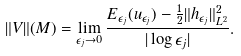Convert formula to latex. <formula><loc_0><loc_0><loc_500><loc_500>\| V \| ( M ) = \lim _ { \epsilon _ { j } \to 0 } \frac { E _ { \epsilon _ { j } } ( u _ { \epsilon _ { j } } ) - \frac { 1 } { 2 } \| h _ { \epsilon _ { j } } \| _ { L ^ { 2 } } ^ { 2 } } { | \log \epsilon _ { j } | } .</formula> 